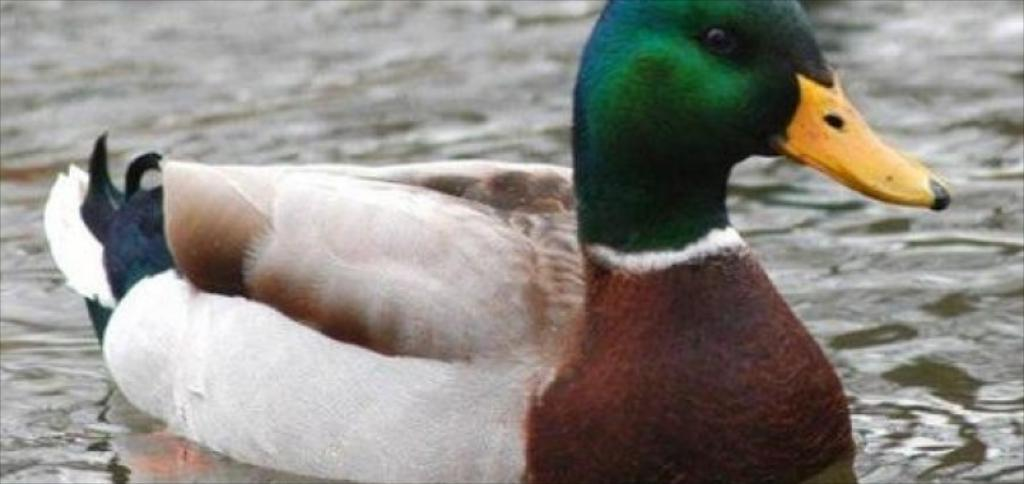What animal is present in the image? There is a duck in the image. What is the duck doing in the image? The duck is swimming in the water. What type of elbow can be seen on the duck in the image? There are no elbows on ducks, as they are birds and have wings instead. 